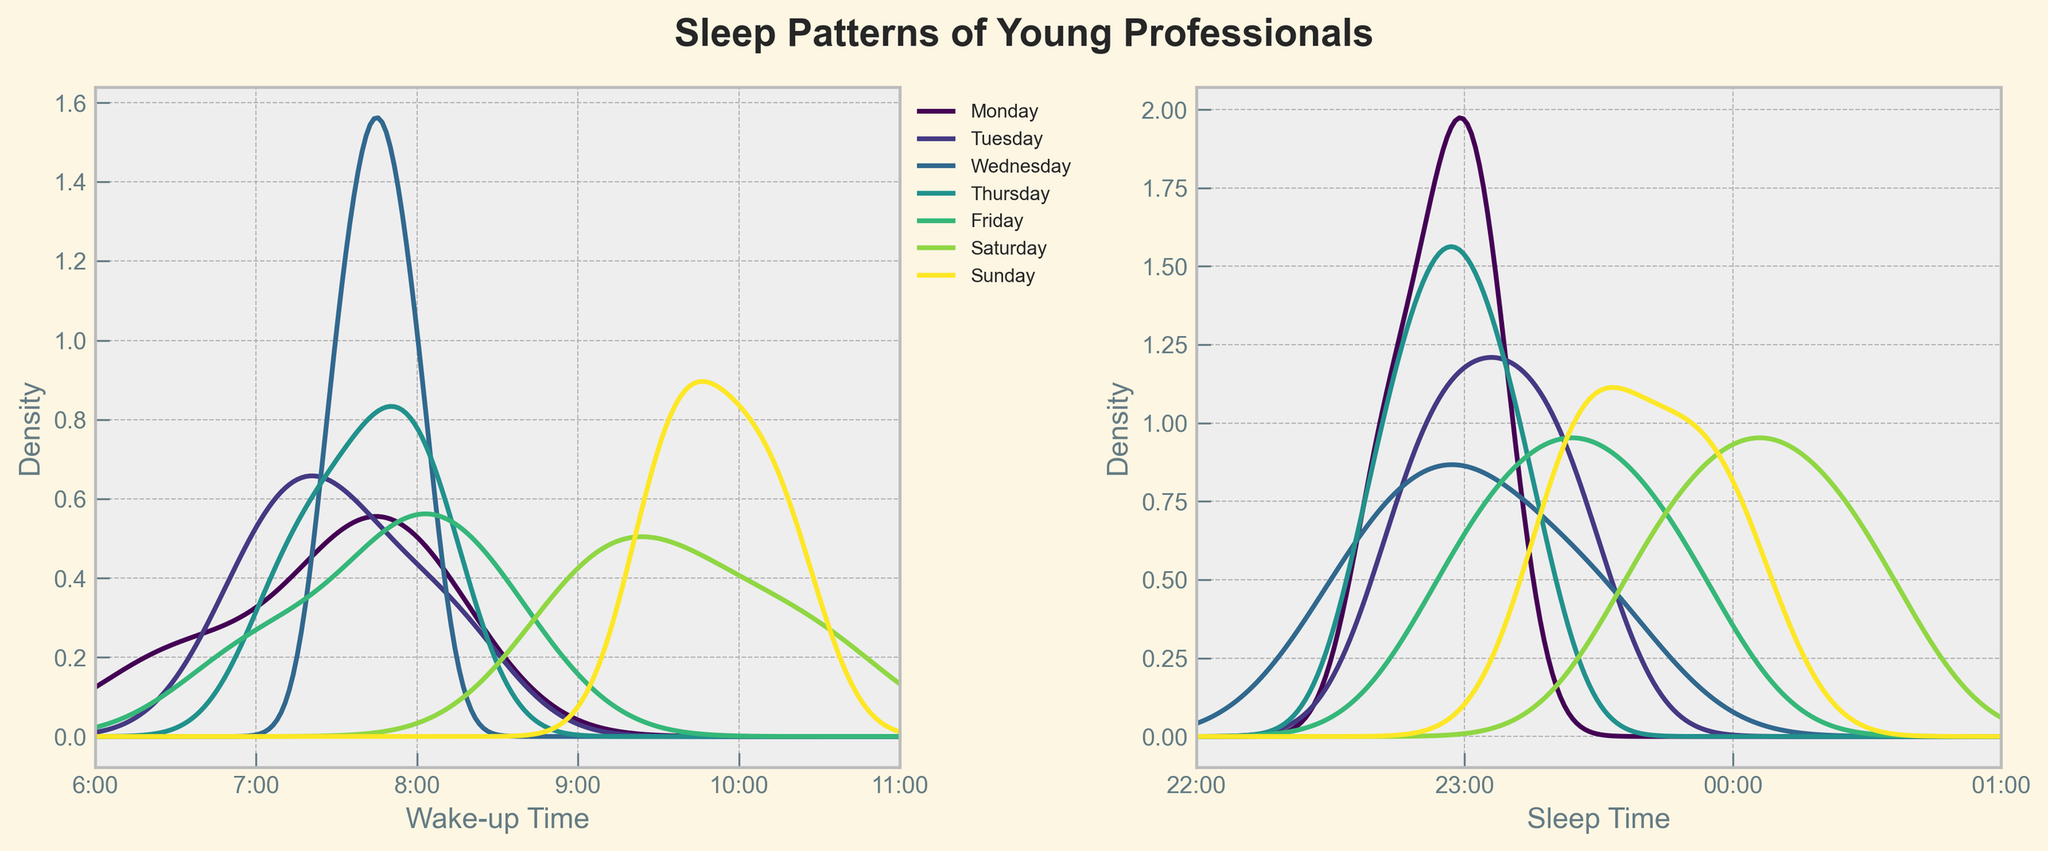What is the title of the figure? The figure's title is displayed at the top of the plot. It reads "Sleep Patterns of Young Professionals," indicating the focus of the plot is on sleep patterns over different days of the week.
Answer: Sleep Patterns of Young Professionals What are the x-axis labels of the wake-up time plot? By looking at the x-axis of the wake-up time plot on the left, we can see it is labeled from '6:00' to '11:00' in hourly increments.
Answer: 6:00, 7:00, 8:00, 9:00, 10:00, 11:00 Which day has the latest average wake-up time? To determine which day has the latest average wake-up time, we can compare the peak densities of the wake-up time plots. The Saturday and Sunday plots have peaks that are furthest right, indicating later wake-up times. By checking visually, Sunday appears to have the latest peak.
Answer: Sunday On which day do young professionals tend to go to sleep the earliest? By observing the sleep time plot on the right, we can find the day with the peak density furthest left. Monday's plot has the peak closest to 22:00, meaning young professionals tend to go to sleep earliest on this day.
Answer: Monday What is the sleep pattern trend from Monday to Sunday? Looking at the density plots from Monday to Sunday, we can see that the wake-up time gradually moves later as the week progresses, particularly on weekends. Similarly, the sleep time also shifts later towards the weekend and becomes latest on Saturday and Sunday.
Answer: Wake-up and sleep times both get later as the week progresses, peaking on weekends Which day shows the most variation in sleep times? Variation in sleep times is indicated by the width of the density plot. The wider the plot, the more variation. Saturday shows a wider distribution from 23:00 to around 24:00, indicating it has the most variation.
Answer: Saturday Is there a significant difference between weekday and weekend sleep patterns? By comparing the plots for weekdays (Monday to Friday) with those for the weekend (Saturday and Sunday), we see a noticeable shift. Weekdays show earlier wake-up and sleep times, whereas weekend plots shift later for both wake-up and sleep times, illustrating a clear difference in sleep patterns.
Answer: Yes, significant difference What are the peak wake-up times for Saturday? The peak of the density plot for Saturday's wake-up times indicates where most data points are clustered. For Saturday, this peak is around 9:00 to 10:00.
Answer: Around 9:00 to 10:00 At what time do most young professionals tend to go to sleep on Friday? By examining the peak of the density plot for Friday's sleep time, we can see that it peaks around 23:30, indicating that most young professionals tend to go to sleep around this time on Friday.
Answer: Around 23:30 